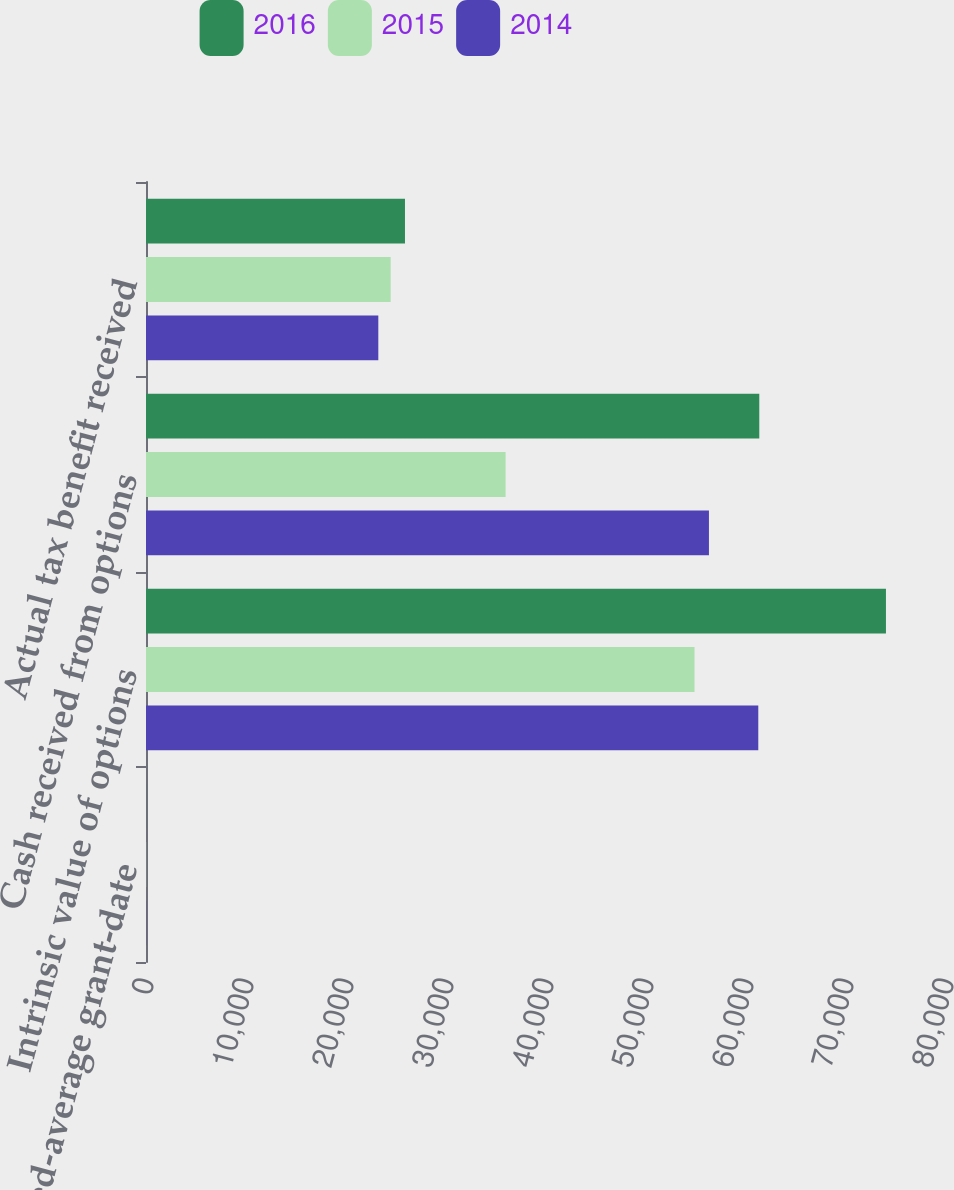Convert chart. <chart><loc_0><loc_0><loc_500><loc_500><stacked_bar_chart><ecel><fcel>Weighted-average grant-date<fcel>Intrinsic value of options<fcel>Cash received from options<fcel>Actual tax benefit received<nl><fcel>2016<fcel>9.04<fcel>73995<fcel>61329<fcel>25898<nl><fcel>2015<fcel>11.97<fcel>54854<fcel>35958<fcel>24470<nl><fcel>2014<fcel>14.77<fcel>61229<fcel>56294<fcel>23232<nl></chart> 